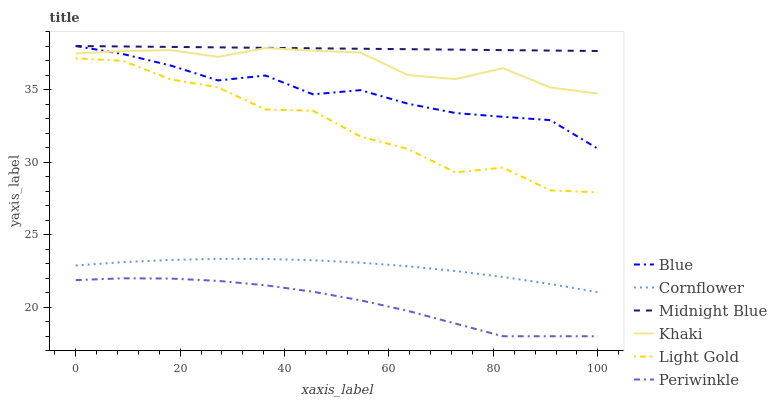Does Periwinkle have the minimum area under the curve?
Answer yes or no. Yes. Does Midnight Blue have the maximum area under the curve?
Answer yes or no. Yes. Does Cornflower have the minimum area under the curve?
Answer yes or no. No. Does Cornflower have the maximum area under the curve?
Answer yes or no. No. Is Midnight Blue the smoothest?
Answer yes or no. Yes. Is Light Gold the roughest?
Answer yes or no. Yes. Is Cornflower the smoothest?
Answer yes or no. No. Is Cornflower the roughest?
Answer yes or no. No. Does Periwinkle have the lowest value?
Answer yes or no. Yes. Does Cornflower have the lowest value?
Answer yes or no. No. Does Midnight Blue have the highest value?
Answer yes or no. Yes. Does Cornflower have the highest value?
Answer yes or no. No. Is Light Gold less than Midnight Blue?
Answer yes or no. Yes. Is Khaki greater than Periwinkle?
Answer yes or no. Yes. Does Midnight Blue intersect Blue?
Answer yes or no. Yes. Is Midnight Blue less than Blue?
Answer yes or no. No. Is Midnight Blue greater than Blue?
Answer yes or no. No. Does Light Gold intersect Midnight Blue?
Answer yes or no. No. 